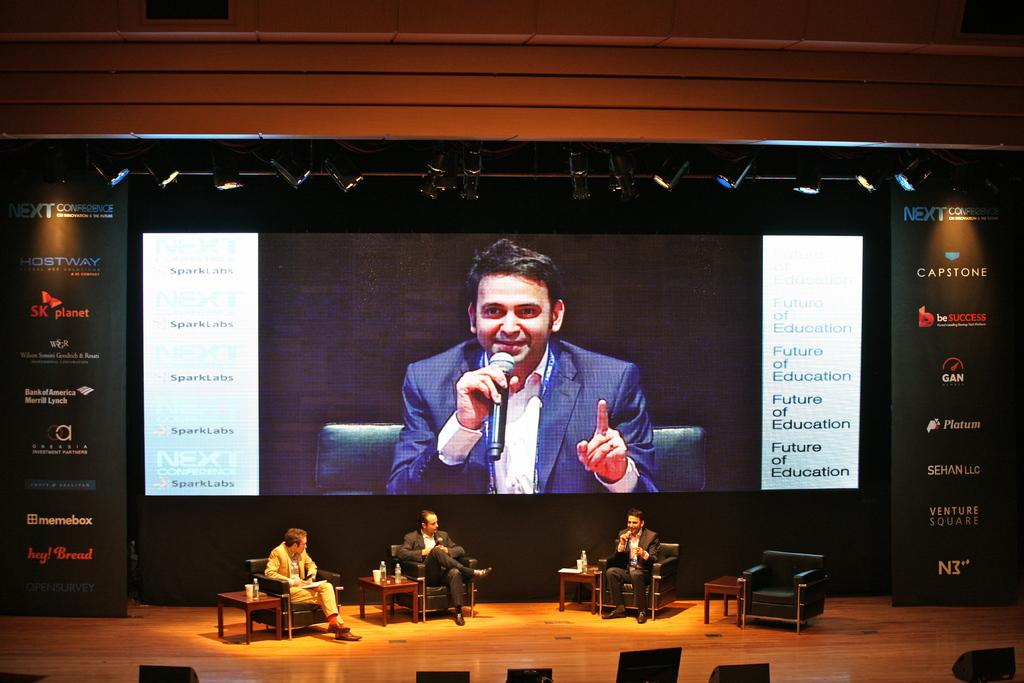<image>
Offer a succinct explanation of the picture presented. A large screen with a person and several captions saying Future of education 